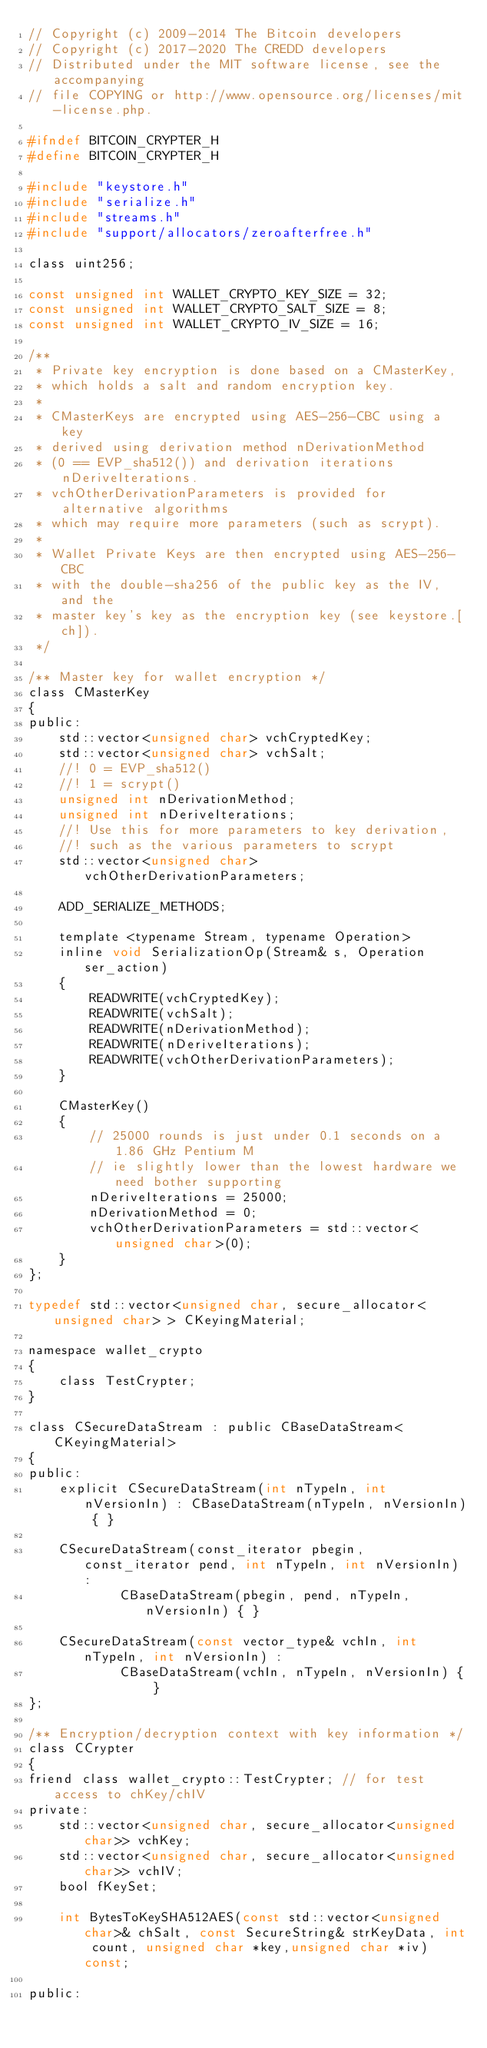<code> <loc_0><loc_0><loc_500><loc_500><_C_>// Copyright (c) 2009-2014 The Bitcoin developers
// Copyright (c) 2017-2020 The CREDD developers
// Distributed under the MIT software license, see the accompanying
// file COPYING or http://www.opensource.org/licenses/mit-license.php.

#ifndef BITCOIN_CRYPTER_H
#define BITCOIN_CRYPTER_H

#include "keystore.h"
#include "serialize.h"
#include "streams.h"
#include "support/allocators/zeroafterfree.h"

class uint256;

const unsigned int WALLET_CRYPTO_KEY_SIZE = 32;
const unsigned int WALLET_CRYPTO_SALT_SIZE = 8;
const unsigned int WALLET_CRYPTO_IV_SIZE = 16;

/**
 * Private key encryption is done based on a CMasterKey,
 * which holds a salt and random encryption key.
 * 
 * CMasterKeys are encrypted using AES-256-CBC using a key
 * derived using derivation method nDerivationMethod
 * (0 == EVP_sha512()) and derivation iterations nDeriveIterations.
 * vchOtherDerivationParameters is provided for alternative algorithms
 * which may require more parameters (such as scrypt).
 * 
 * Wallet Private Keys are then encrypted using AES-256-CBC
 * with the double-sha256 of the public key as the IV, and the
 * master key's key as the encryption key (see keystore.[ch]).
 */

/** Master key for wallet encryption */
class CMasterKey
{
public:
    std::vector<unsigned char> vchCryptedKey;
    std::vector<unsigned char> vchSalt;
    //! 0 = EVP_sha512()
    //! 1 = scrypt()
    unsigned int nDerivationMethod;
    unsigned int nDeriveIterations;
    //! Use this for more parameters to key derivation,
    //! such as the various parameters to scrypt
    std::vector<unsigned char> vchOtherDerivationParameters;

    ADD_SERIALIZE_METHODS;

    template <typename Stream, typename Operation>
    inline void SerializationOp(Stream& s, Operation ser_action)
    {
        READWRITE(vchCryptedKey);
        READWRITE(vchSalt);
        READWRITE(nDerivationMethod);
        READWRITE(nDeriveIterations);
        READWRITE(vchOtherDerivationParameters);
    }

    CMasterKey()
    {
        // 25000 rounds is just under 0.1 seconds on a 1.86 GHz Pentium M
        // ie slightly lower than the lowest hardware we need bother supporting
        nDeriveIterations = 25000;
        nDerivationMethod = 0;
        vchOtherDerivationParameters = std::vector<unsigned char>(0);
    }
};

typedef std::vector<unsigned char, secure_allocator<unsigned char> > CKeyingMaterial;

namespace wallet_crypto
{
    class TestCrypter;
}

class CSecureDataStream : public CBaseDataStream<CKeyingMaterial>
{
public:
    explicit CSecureDataStream(int nTypeIn, int nVersionIn) : CBaseDataStream(nTypeIn, nVersionIn) { }

    CSecureDataStream(const_iterator pbegin, const_iterator pend, int nTypeIn, int nVersionIn) :
            CBaseDataStream(pbegin, pend, nTypeIn, nVersionIn) { }

    CSecureDataStream(const vector_type& vchIn, int nTypeIn, int nVersionIn) :
            CBaseDataStream(vchIn, nTypeIn, nVersionIn) { }
};

/** Encryption/decryption context with key information */
class CCrypter
{
friend class wallet_crypto::TestCrypter; // for test access to chKey/chIV
private:
    std::vector<unsigned char, secure_allocator<unsigned char>> vchKey;
    std::vector<unsigned char, secure_allocator<unsigned char>> vchIV;
    bool fKeySet;

    int BytesToKeySHA512AES(const std::vector<unsigned char>& chSalt, const SecureString& strKeyData, int count, unsigned char *key,unsigned char *iv) const;

public:</code> 